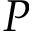Convert formula to latex. <formula><loc_0><loc_0><loc_500><loc_500>P</formula> 